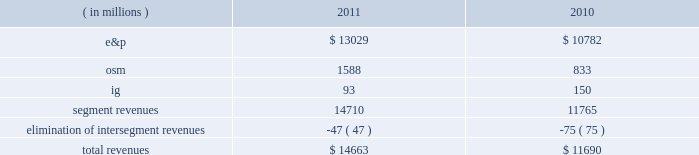2022 increased proved liquid hydrocarbon , including synthetic crude oil , reserves to 78 percent from 75 percent of proved reserves 2022 increased e&p net sales volumes , excluding libya , by 7 percent 2022 recorded 96 percent average operational availability for all major company-operated e&p assets , compared to 94 percent in 2010 2022 completed debottlenecking work that increased crude oil production capacity at the alvheim fpso in norway to 150000 gross bbld from the previous capacity of 142000 gross bbld and the original 2008 capacity of 120000 gross bbld 2022 announced two non-operated discoveries in the iraqi kurdistan region and began drilling in poland 2022 completed aosp expansion 1 , including the start-up of the expanded scotford upgrader , realizing an increase in net synthetic crude oil sales volumes of 48 percent 2022 completed dispositions of non-core assets and interests in acreage positions for net proceeds of $ 518 million 2022 repurchased 12 million shares of our common stock at a cost of $ 300 million 2022 retired $ 2498 million principal of our long-term debt 2022 resumed limited production in libya in the fourth quarter of 2011 following the february 2011 temporary suspension of operations consolidated results of operations : 2011 compared to 2010 due to the spin-off of our downstream business on june 30 , 2011 , which is reported as discontinued operations , income from continuing operations is more representative of marathon oil as an independent energy company .
Consolidated income from continuing operations before income taxes was 9 percent higher in 2011 than in 2010 , largely due to higher liquid hydrocarbon prices .
This improvement was offset by increased income taxes primarily the result of excess foreign tax credits generated during 2011 that we do not expect to utilize in the future .
The effective income tax rate for continuing operations was 61 percent in 2011 compared to 54 percent in 2010 .
Revenues are summarized in the table : ( in millions ) 2011 2010 .
E&p segment revenues increased $ 2247 million from 2010 to 2011 , primarily due to higher average liquid hydrocarbon realizations , which were $ 99.37 per bbl in 2011 , a 31 percent increase over 2010 .
Revenues in 2010 included net pre-tax gains of $ 95 million on derivative instruments intended to mitigate price risk on future sales of liquid hydrocarbons and natural gas .
Included in our e&p segment are supply optimization activities which include the purchase of commodities from third parties for resale .
Supply optimization serves to aggregate volumes in order to satisfy transportation commitments and to achieve flexibility within product types and delivery points .
See the cost of revenues discussion as revenues from supply optimization approximate the related costs .
Higher average crude oil prices in 2011 compared to 2010 increased revenues related to supply optimization .
Revenues from the sale of our u.s .
Production are higher in 2011 primarily as a result of higher liquid hydrocarbon and natural gas price realizations , but sales volumes declined. .
For the completed debottlenecking work that increased crude oil production capacity at the alvheim fpso in norway , what was the increase in gross bbld from the previous capacity? 
Computations: (150000 - 142000)
Answer: 8000.0. 